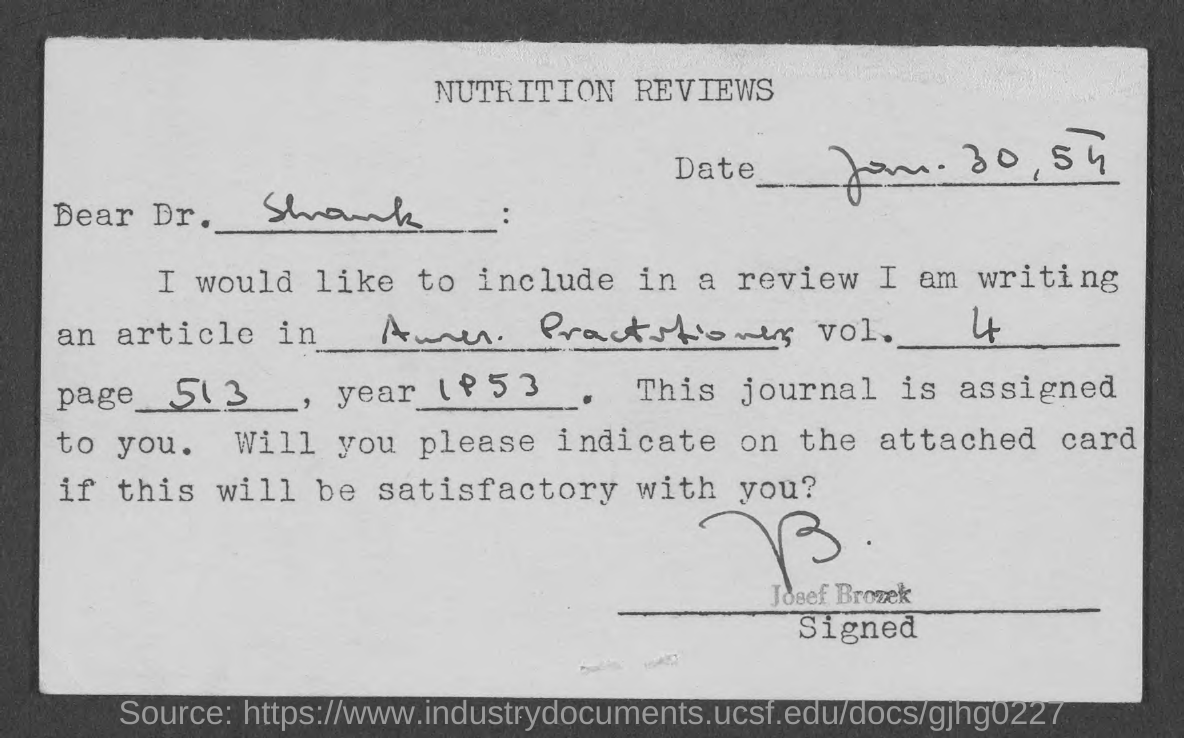Give some essential details in this illustration. The heading of the page is "Nutrition Reviews. 